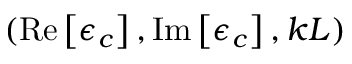<formula> <loc_0><loc_0><loc_500><loc_500>( R e \left [ \epsilon _ { c } \right ] , I m \left [ \epsilon _ { c } \right ] , k L )</formula> 